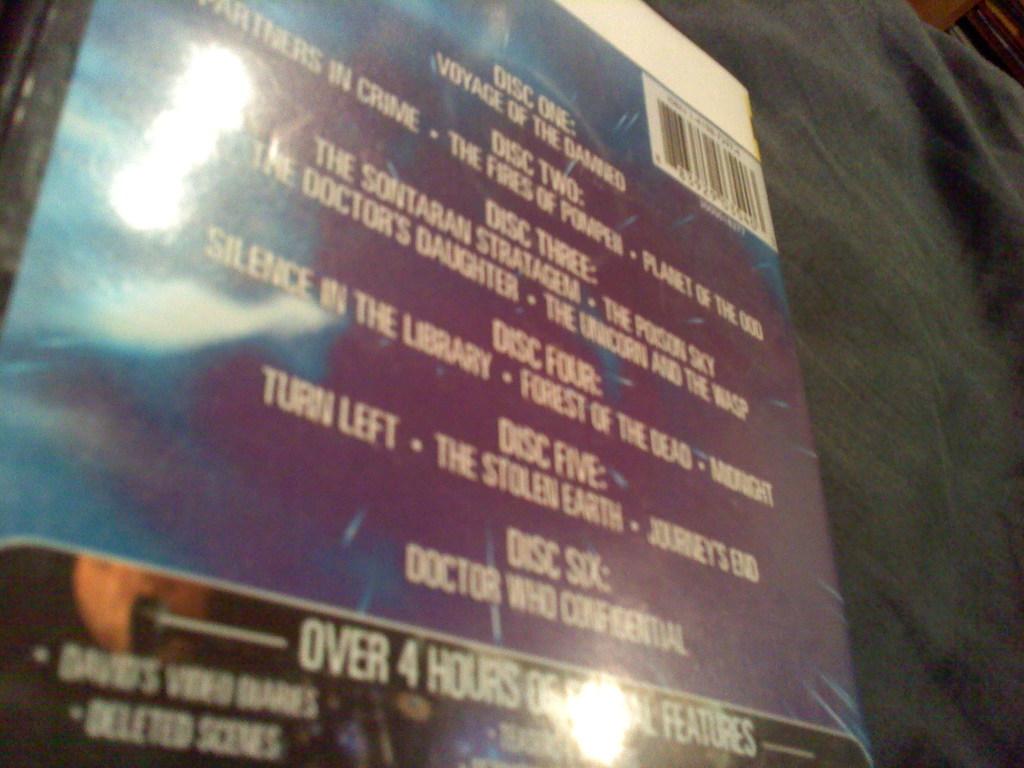What is the first track on disc five?
Make the answer very short. Turn left. 